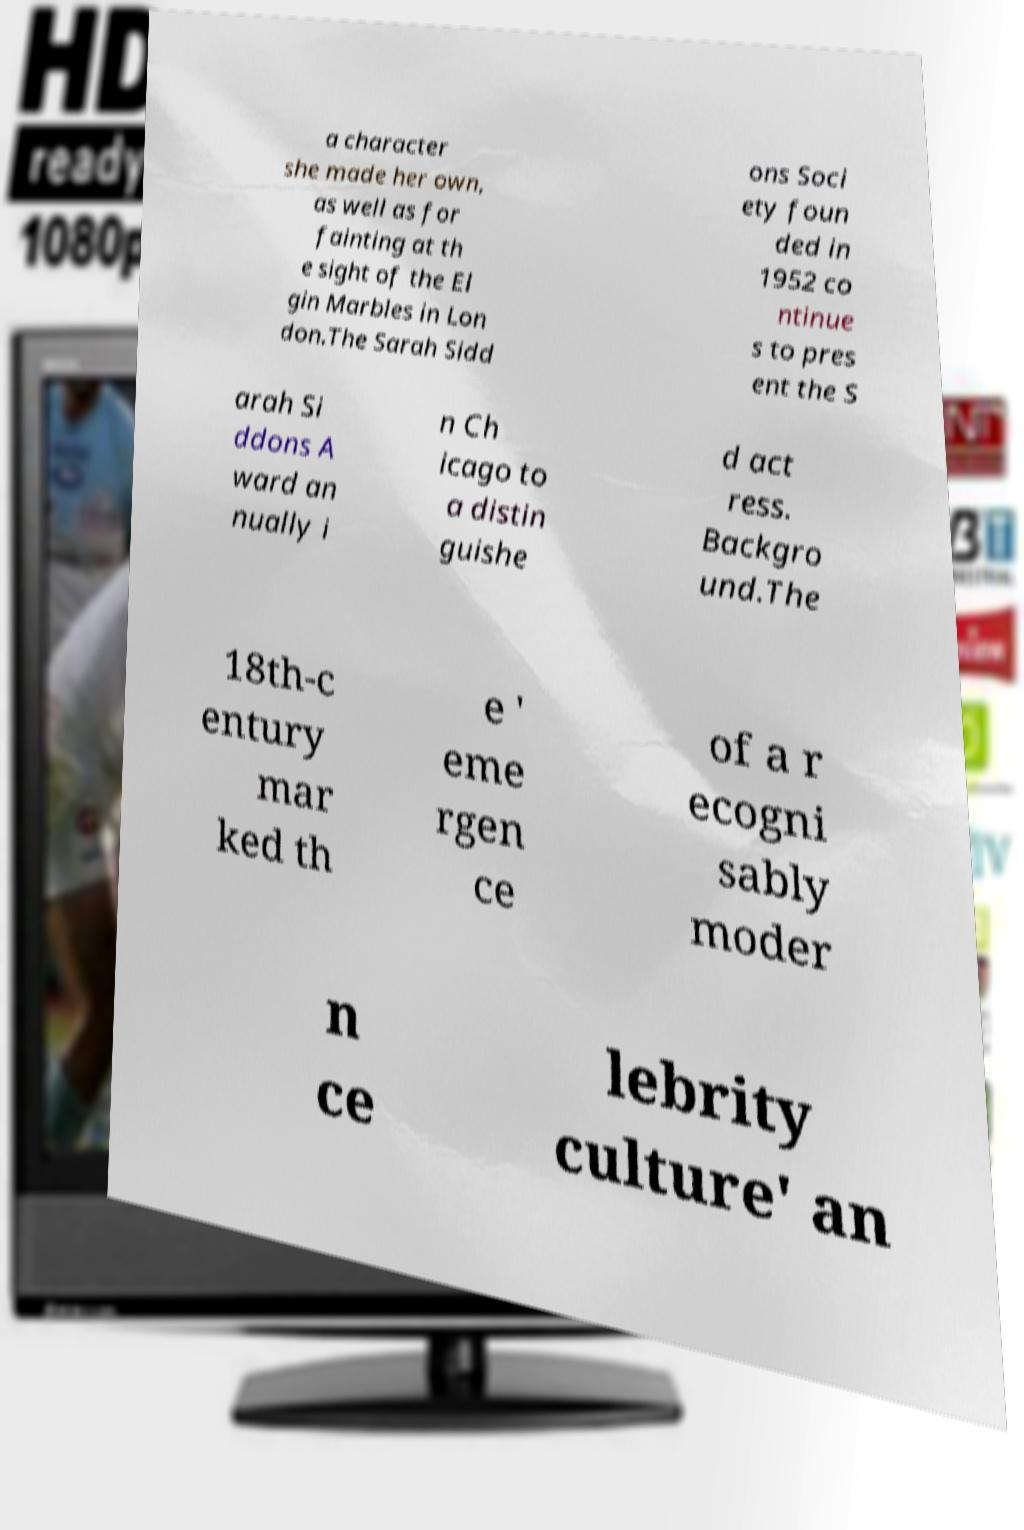Could you extract and type out the text from this image? a character she made her own, as well as for fainting at th e sight of the El gin Marbles in Lon don.The Sarah Sidd ons Soci ety foun ded in 1952 co ntinue s to pres ent the S arah Si ddons A ward an nually i n Ch icago to a distin guishe d act ress. Backgro und.The 18th-c entury mar ked th e ' eme rgen ce of a r ecogni sably moder n ce lebrity culture' an 